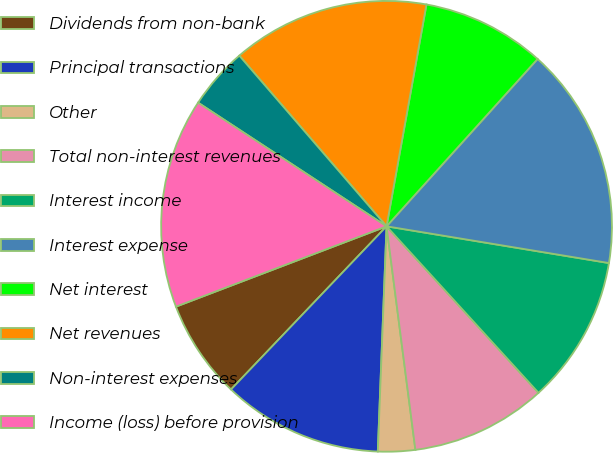Convert chart to OTSL. <chart><loc_0><loc_0><loc_500><loc_500><pie_chart><fcel>Dividends from non-bank<fcel>Principal transactions<fcel>Other<fcel>Total non-interest revenues<fcel>Interest income<fcel>Interest expense<fcel>Net interest<fcel>Net revenues<fcel>Non-interest expenses<fcel>Income (loss) before provision<nl><fcel>7.08%<fcel>11.5%<fcel>2.66%<fcel>9.73%<fcel>10.62%<fcel>15.92%<fcel>8.85%<fcel>14.16%<fcel>4.43%<fcel>15.04%<nl></chart> 